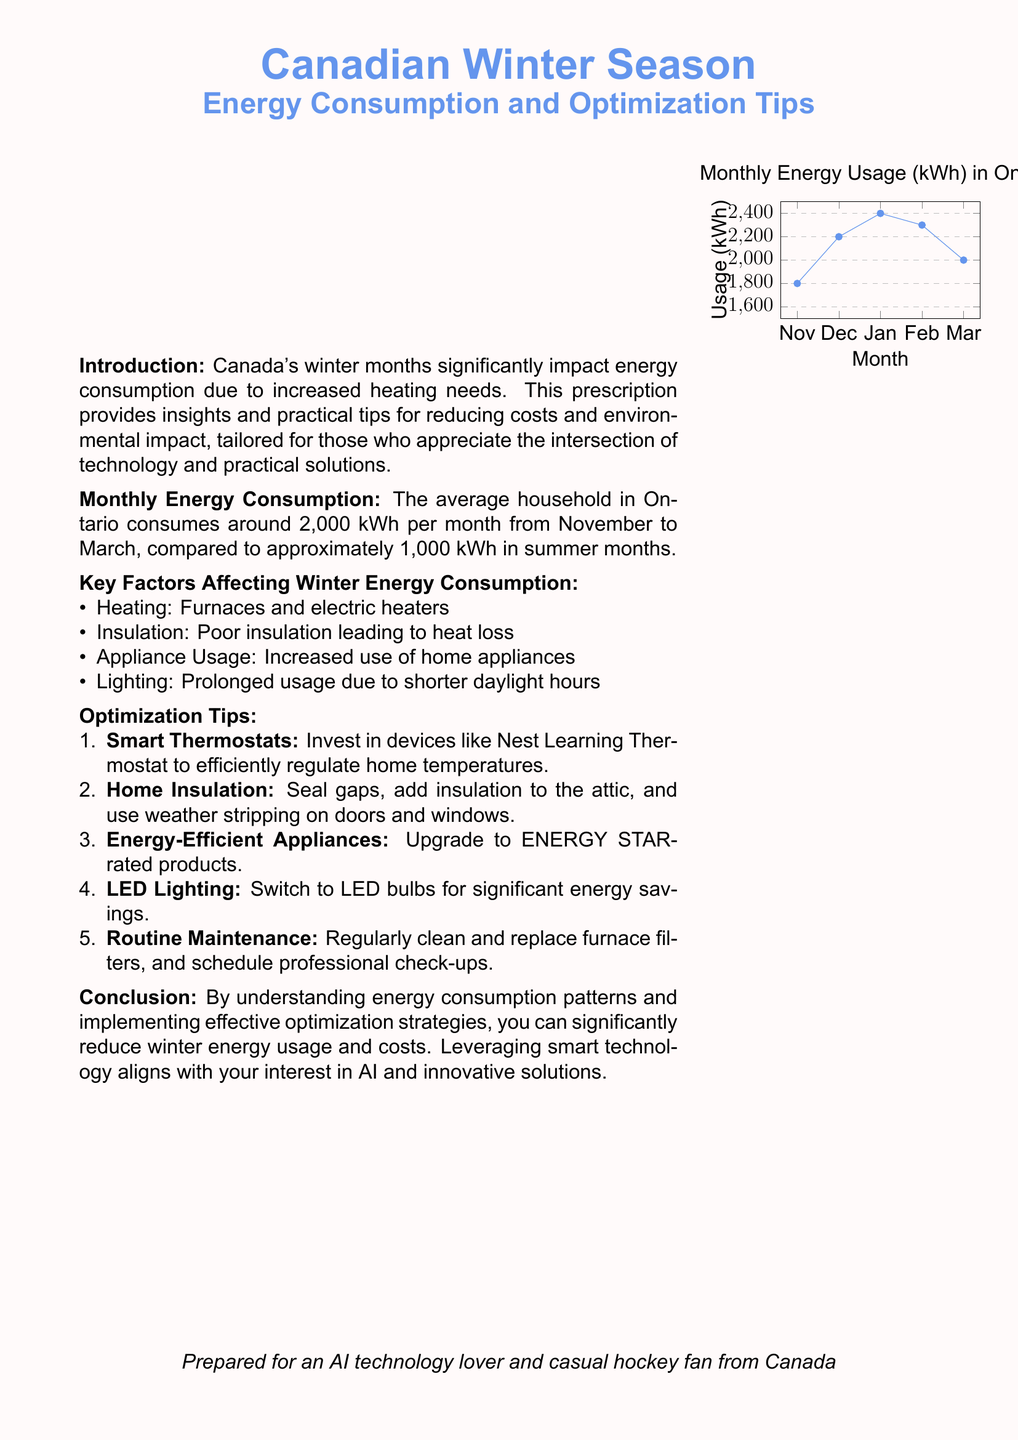What is the average monthly energy consumption in Ontario during winter? The document states that the average household in Ontario consumes around 2,000 kWh per month from November to March.
Answer: 2000 kWh Which smart device is recommended for regulating home temperatures? The document suggests investing in devices like the Nest Learning Thermostat.
Answer: Nest Learning Thermostat What is the highest energy usage recorded in January? The usage for January is specified as 2400 kWh in the monthly usage graph.
Answer: 2400 kWh What key factor affects energy consumption related to natural light? The document mentions prolonged usage due to shorter daylight hours as a key factor affecting energy consumption.
Answer: Shorter daylight hours How many optimization tips are provided in the document? The document lists a total of five optimization tips for reducing energy consumption.
Answer: Five 